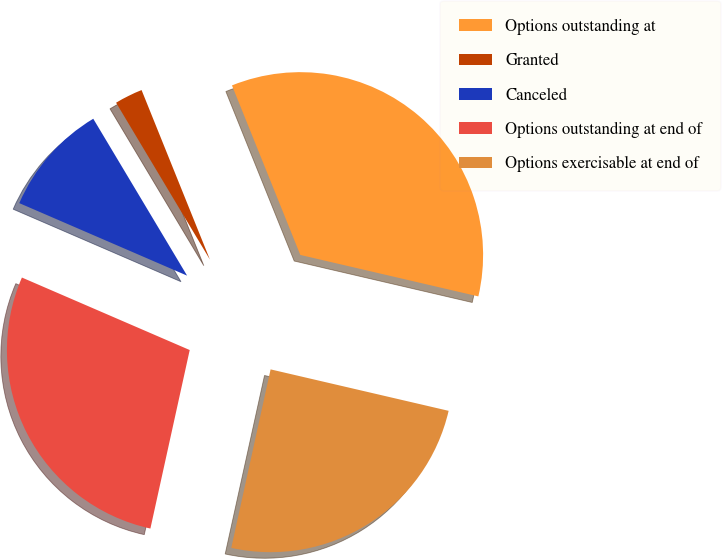Convert chart. <chart><loc_0><loc_0><loc_500><loc_500><pie_chart><fcel>Options outstanding at<fcel>Granted<fcel>Canceled<fcel>Options outstanding at end of<fcel>Options exercisable at end of<nl><fcel>34.74%<fcel>2.48%<fcel>9.93%<fcel>28.04%<fcel>24.81%<nl></chart> 